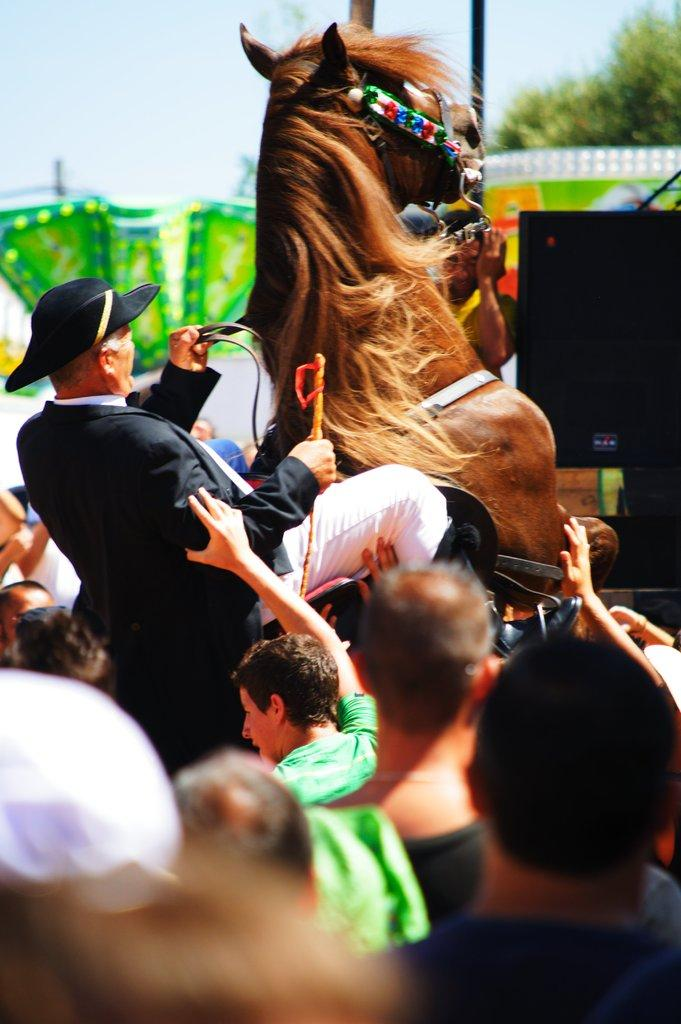What is the man in the image doing? The man is sitting on a horse. What can be seen in the background of the image? There is a group of people standing in the background. What is visible at the top of the image? The sky is visible in the image. What type of light is being used for reading in the image? There is no indication of reading or any light source in the image. 